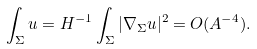Convert formula to latex. <formula><loc_0><loc_0><loc_500><loc_500>\int _ { \Sigma } u = H ^ { - 1 } \int _ { \Sigma } | \nabla _ { \Sigma } u | ^ { 2 } = O ( A ^ { - 4 } ) .</formula> 